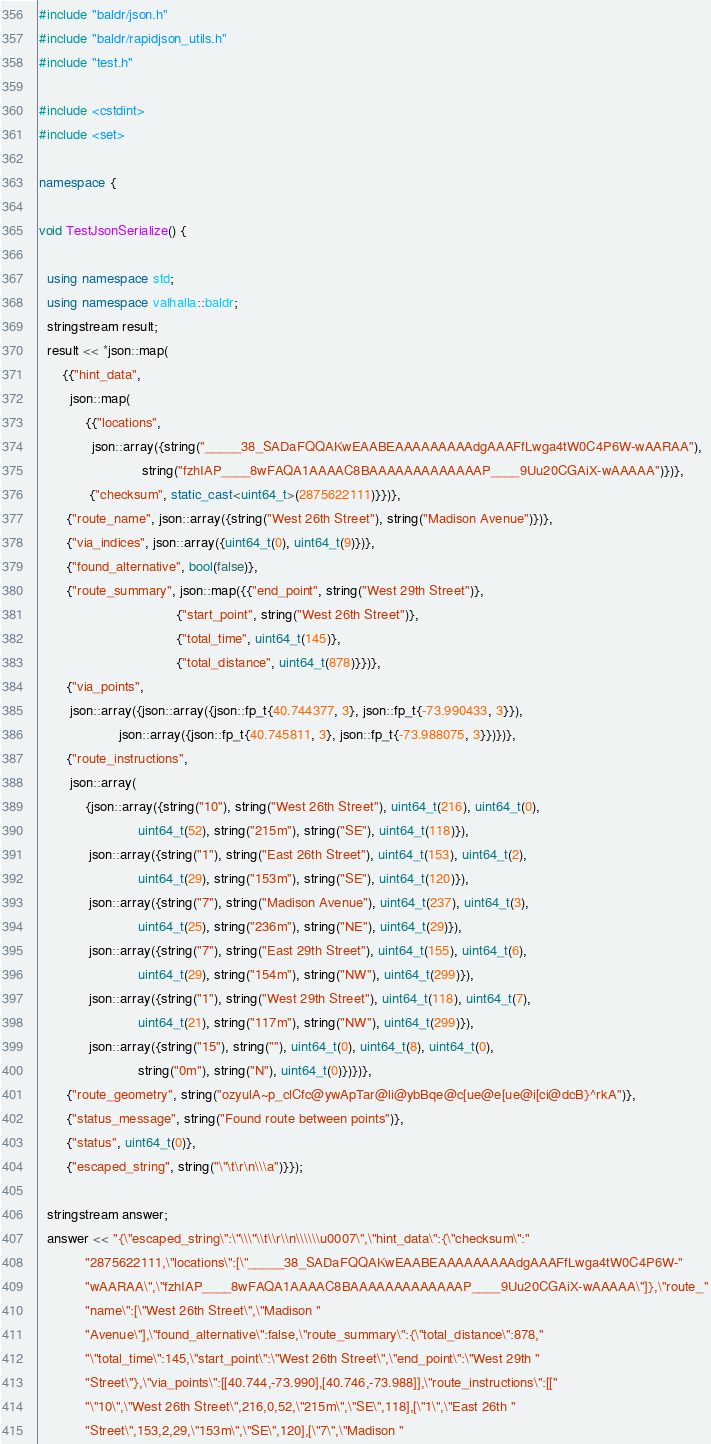<code> <loc_0><loc_0><loc_500><loc_500><_C++_>#include "baldr/json.h"
#include "baldr/rapidjson_utils.h"
#include "test.h"

#include <cstdint>
#include <set>

namespace {

void TestJsonSerialize() {

  using namespace std;
  using namespace valhalla::baldr;
  stringstream result;
  result << *json::map(
      {{"hint_data",
        json::map(
            {{"locations",
              json::array({string("_____38_SADaFQQAKwEAABEAAAAAAAAAdgAAAFfLwga4tW0C4P6W-wAARAA"),
                           string("fzhIAP____8wFAQA1AAAAC8BAAAAAAAAAAAAAP____9Uu20CGAiX-wAAAAA")})},
             {"checksum", static_cast<uint64_t>(2875622111)}})},
       {"route_name", json::array({string("West 26th Street"), string("Madison Avenue")})},
       {"via_indices", json::array({uint64_t(0), uint64_t(9)})},
       {"found_alternative", bool(false)},
       {"route_summary", json::map({{"end_point", string("West 29th Street")},
                                    {"start_point", string("West 26th Street")},
                                    {"total_time", uint64_t(145)},
                                    {"total_distance", uint64_t(878)}})},
       {"via_points",
        json::array({json::array({json::fp_t{40.744377, 3}, json::fp_t{-73.990433, 3}}),
                     json::array({json::fp_t{40.745811, 3}, json::fp_t{-73.988075, 3}})})},
       {"route_instructions",
        json::array(
            {json::array({string("10"), string("West 26th Street"), uint64_t(216), uint64_t(0),
                          uint64_t(52), string("215m"), string("SE"), uint64_t(118)}),
             json::array({string("1"), string("East 26th Street"), uint64_t(153), uint64_t(2),
                          uint64_t(29), string("153m"), string("SE"), uint64_t(120)}),
             json::array({string("7"), string("Madison Avenue"), uint64_t(237), uint64_t(3),
                          uint64_t(25), string("236m"), string("NE"), uint64_t(29)}),
             json::array({string("7"), string("East 29th Street"), uint64_t(155), uint64_t(6),
                          uint64_t(29), string("154m"), string("NW"), uint64_t(299)}),
             json::array({string("1"), string("West 29th Street"), uint64_t(118), uint64_t(7),
                          uint64_t(21), string("117m"), string("NW"), uint64_t(299)}),
             json::array({string("15"), string(""), uint64_t(0), uint64_t(8), uint64_t(0),
                          string("0m"), string("N"), uint64_t(0)})})},
       {"route_geometry", string("ozyulA~p_clCfc@ywApTar@li@ybBqe@c[ue@e[ue@i[ci@dcB}^rkA")},
       {"status_message", string("Found route between points")},
       {"status", uint64_t(0)},
       {"escaped_string", string("\"\t\r\n\\\a")}});

  stringstream answer;
  answer << "{\"escaped_string\":\"\\\"\\t\\r\\n\\\\\\u0007\",\"hint_data\":{\"checksum\":"
            "2875622111,\"locations\":[\"_____38_SADaFQQAKwEAABEAAAAAAAAAdgAAAFfLwga4tW0C4P6W-"
            "wAARAA\",\"fzhIAP____8wFAQA1AAAAC8BAAAAAAAAAAAAAP____9Uu20CGAiX-wAAAAA\"]},\"route_"
            "name\":[\"West 26th Street\",\"Madison "
            "Avenue\"],\"found_alternative\":false,\"route_summary\":{\"total_distance\":878,"
            "\"total_time\":145,\"start_point\":\"West 26th Street\",\"end_point\":\"West 29th "
            "Street\"},\"via_points\":[[40.744,-73.990],[40.746,-73.988]],\"route_instructions\":[["
            "\"10\",\"West 26th Street\",216,0,52,\"215m\",\"SE\",118],[\"1\",\"East 26th "
            "Street\",153,2,29,\"153m\",\"SE\",120],[\"7\",\"Madison "</code> 